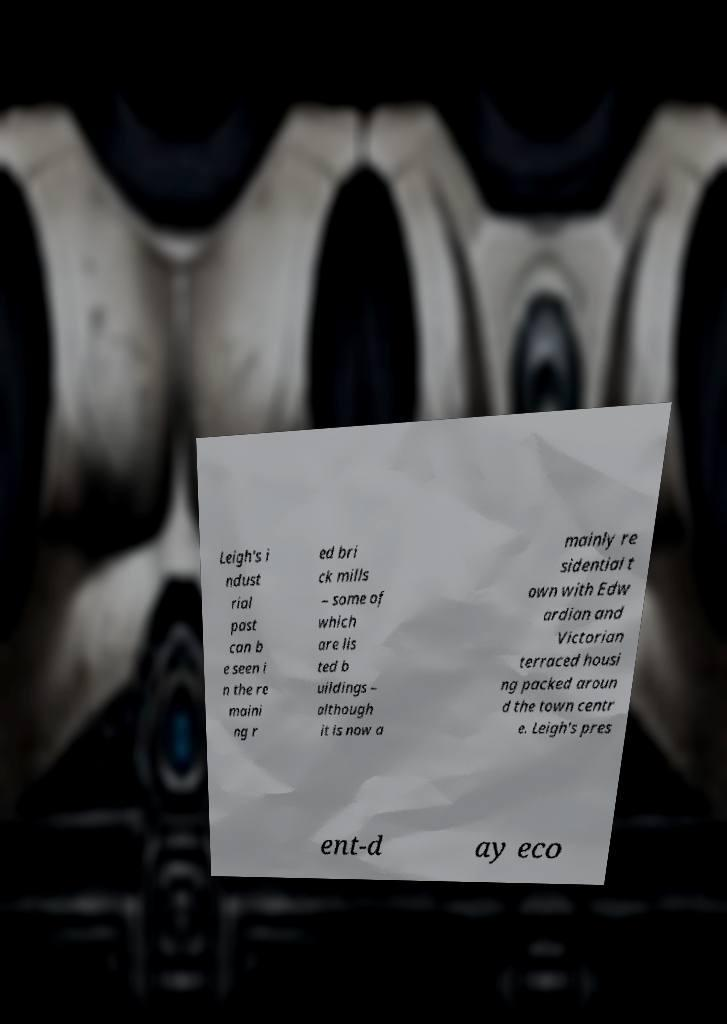Can you accurately transcribe the text from the provided image for me? Leigh's i ndust rial past can b e seen i n the re maini ng r ed bri ck mills – some of which are lis ted b uildings – although it is now a mainly re sidential t own with Edw ardian and Victorian terraced housi ng packed aroun d the town centr e. Leigh's pres ent-d ay eco 